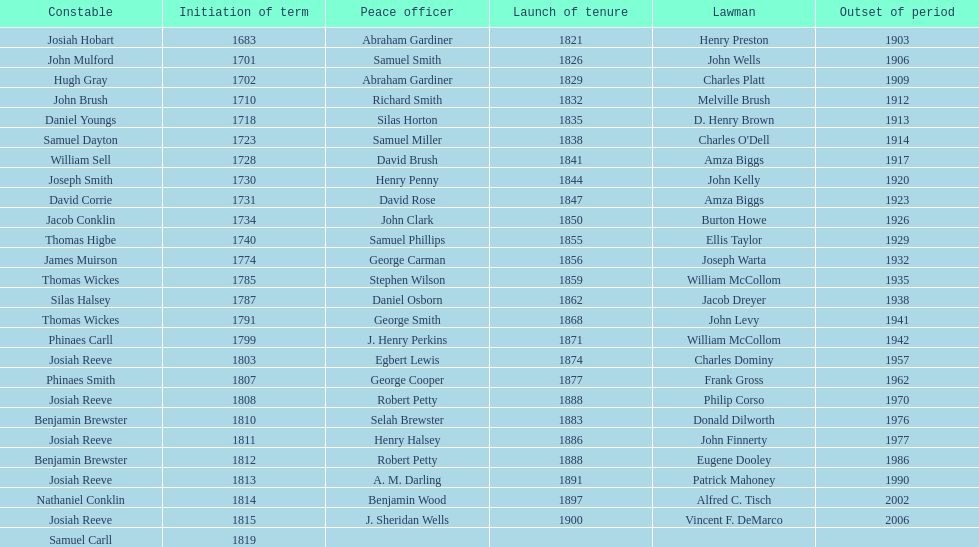When did the first sheriff's term start? 1683. Would you be able to parse every entry in this table? {'header': ['Constable', 'Initiation of term', 'Peace officer', 'Launch of tenure', 'Lawman', 'Outset of period'], 'rows': [['Josiah Hobart', '1683', 'Abraham Gardiner', '1821', 'Henry Preston', '1903'], ['John Mulford', '1701', 'Samuel Smith', '1826', 'John Wells', '1906'], ['Hugh Gray', '1702', 'Abraham Gardiner', '1829', 'Charles Platt', '1909'], ['John Brush', '1710', 'Richard Smith', '1832', 'Melville Brush', '1912'], ['Daniel Youngs', '1718', 'Silas Horton', '1835', 'D. Henry Brown', '1913'], ['Samuel Dayton', '1723', 'Samuel Miller', '1838', "Charles O'Dell", '1914'], ['William Sell', '1728', 'David Brush', '1841', 'Amza Biggs', '1917'], ['Joseph Smith', '1730', 'Henry Penny', '1844', 'John Kelly', '1920'], ['David Corrie', '1731', 'David Rose', '1847', 'Amza Biggs', '1923'], ['Jacob Conklin', '1734', 'John Clark', '1850', 'Burton Howe', '1926'], ['Thomas Higbe', '1740', 'Samuel Phillips', '1855', 'Ellis Taylor', '1929'], ['James Muirson', '1774', 'George Carman', '1856', 'Joseph Warta', '1932'], ['Thomas Wickes', '1785', 'Stephen Wilson', '1859', 'William McCollom', '1935'], ['Silas Halsey', '1787', 'Daniel Osborn', '1862', 'Jacob Dreyer', '1938'], ['Thomas Wickes', '1791', 'George Smith', '1868', 'John Levy', '1941'], ['Phinaes Carll', '1799', 'J. Henry Perkins', '1871', 'William McCollom', '1942'], ['Josiah Reeve', '1803', 'Egbert Lewis', '1874', 'Charles Dominy', '1957'], ['Phinaes Smith', '1807', 'George Cooper', '1877', 'Frank Gross', '1962'], ['Josiah Reeve', '1808', 'Robert Petty', '1888', 'Philip Corso', '1970'], ['Benjamin Brewster', '1810', 'Selah Brewster', '1883', 'Donald Dilworth', '1976'], ['Josiah Reeve', '1811', 'Henry Halsey', '1886', 'John Finnerty', '1977'], ['Benjamin Brewster', '1812', 'Robert Petty', '1888', 'Eugene Dooley', '1986'], ['Josiah Reeve', '1813', 'A. M. Darling', '1891', 'Patrick Mahoney', '1990'], ['Nathaniel Conklin', '1814', 'Benjamin Wood', '1897', 'Alfred C. Tisch', '2002'], ['Josiah Reeve', '1815', 'J. Sheridan Wells', '1900', 'Vincent F. DeMarco', '2006'], ['Samuel Carll', '1819', '', '', '', '']]} 